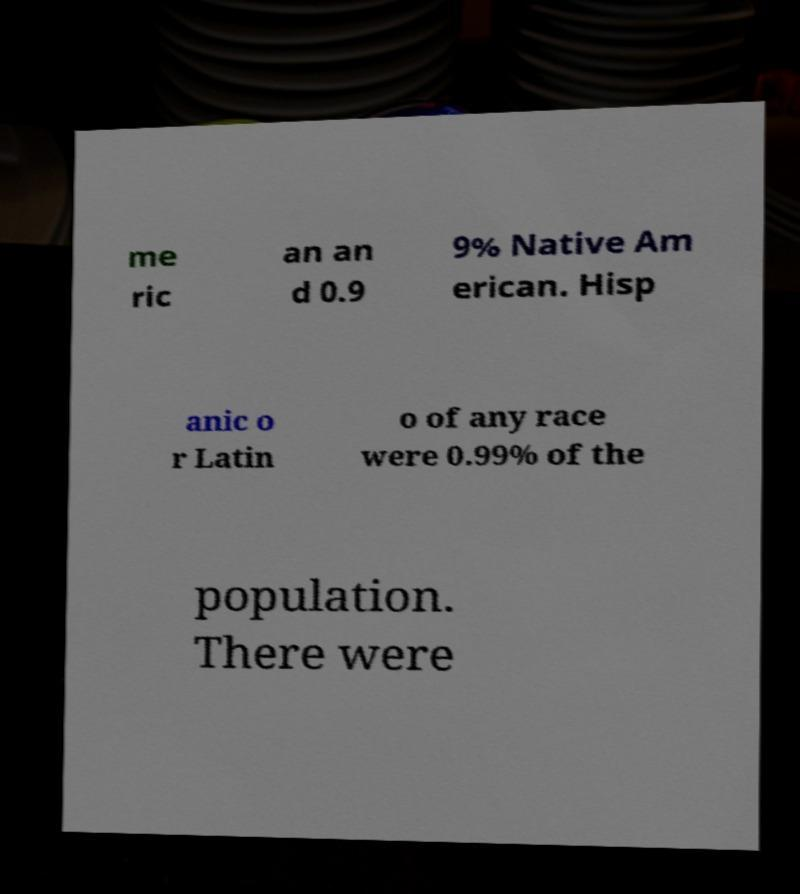I need the written content from this picture converted into text. Can you do that? me ric an an d 0.9 9% Native Am erican. Hisp anic o r Latin o of any race were 0.99% of the population. There were 